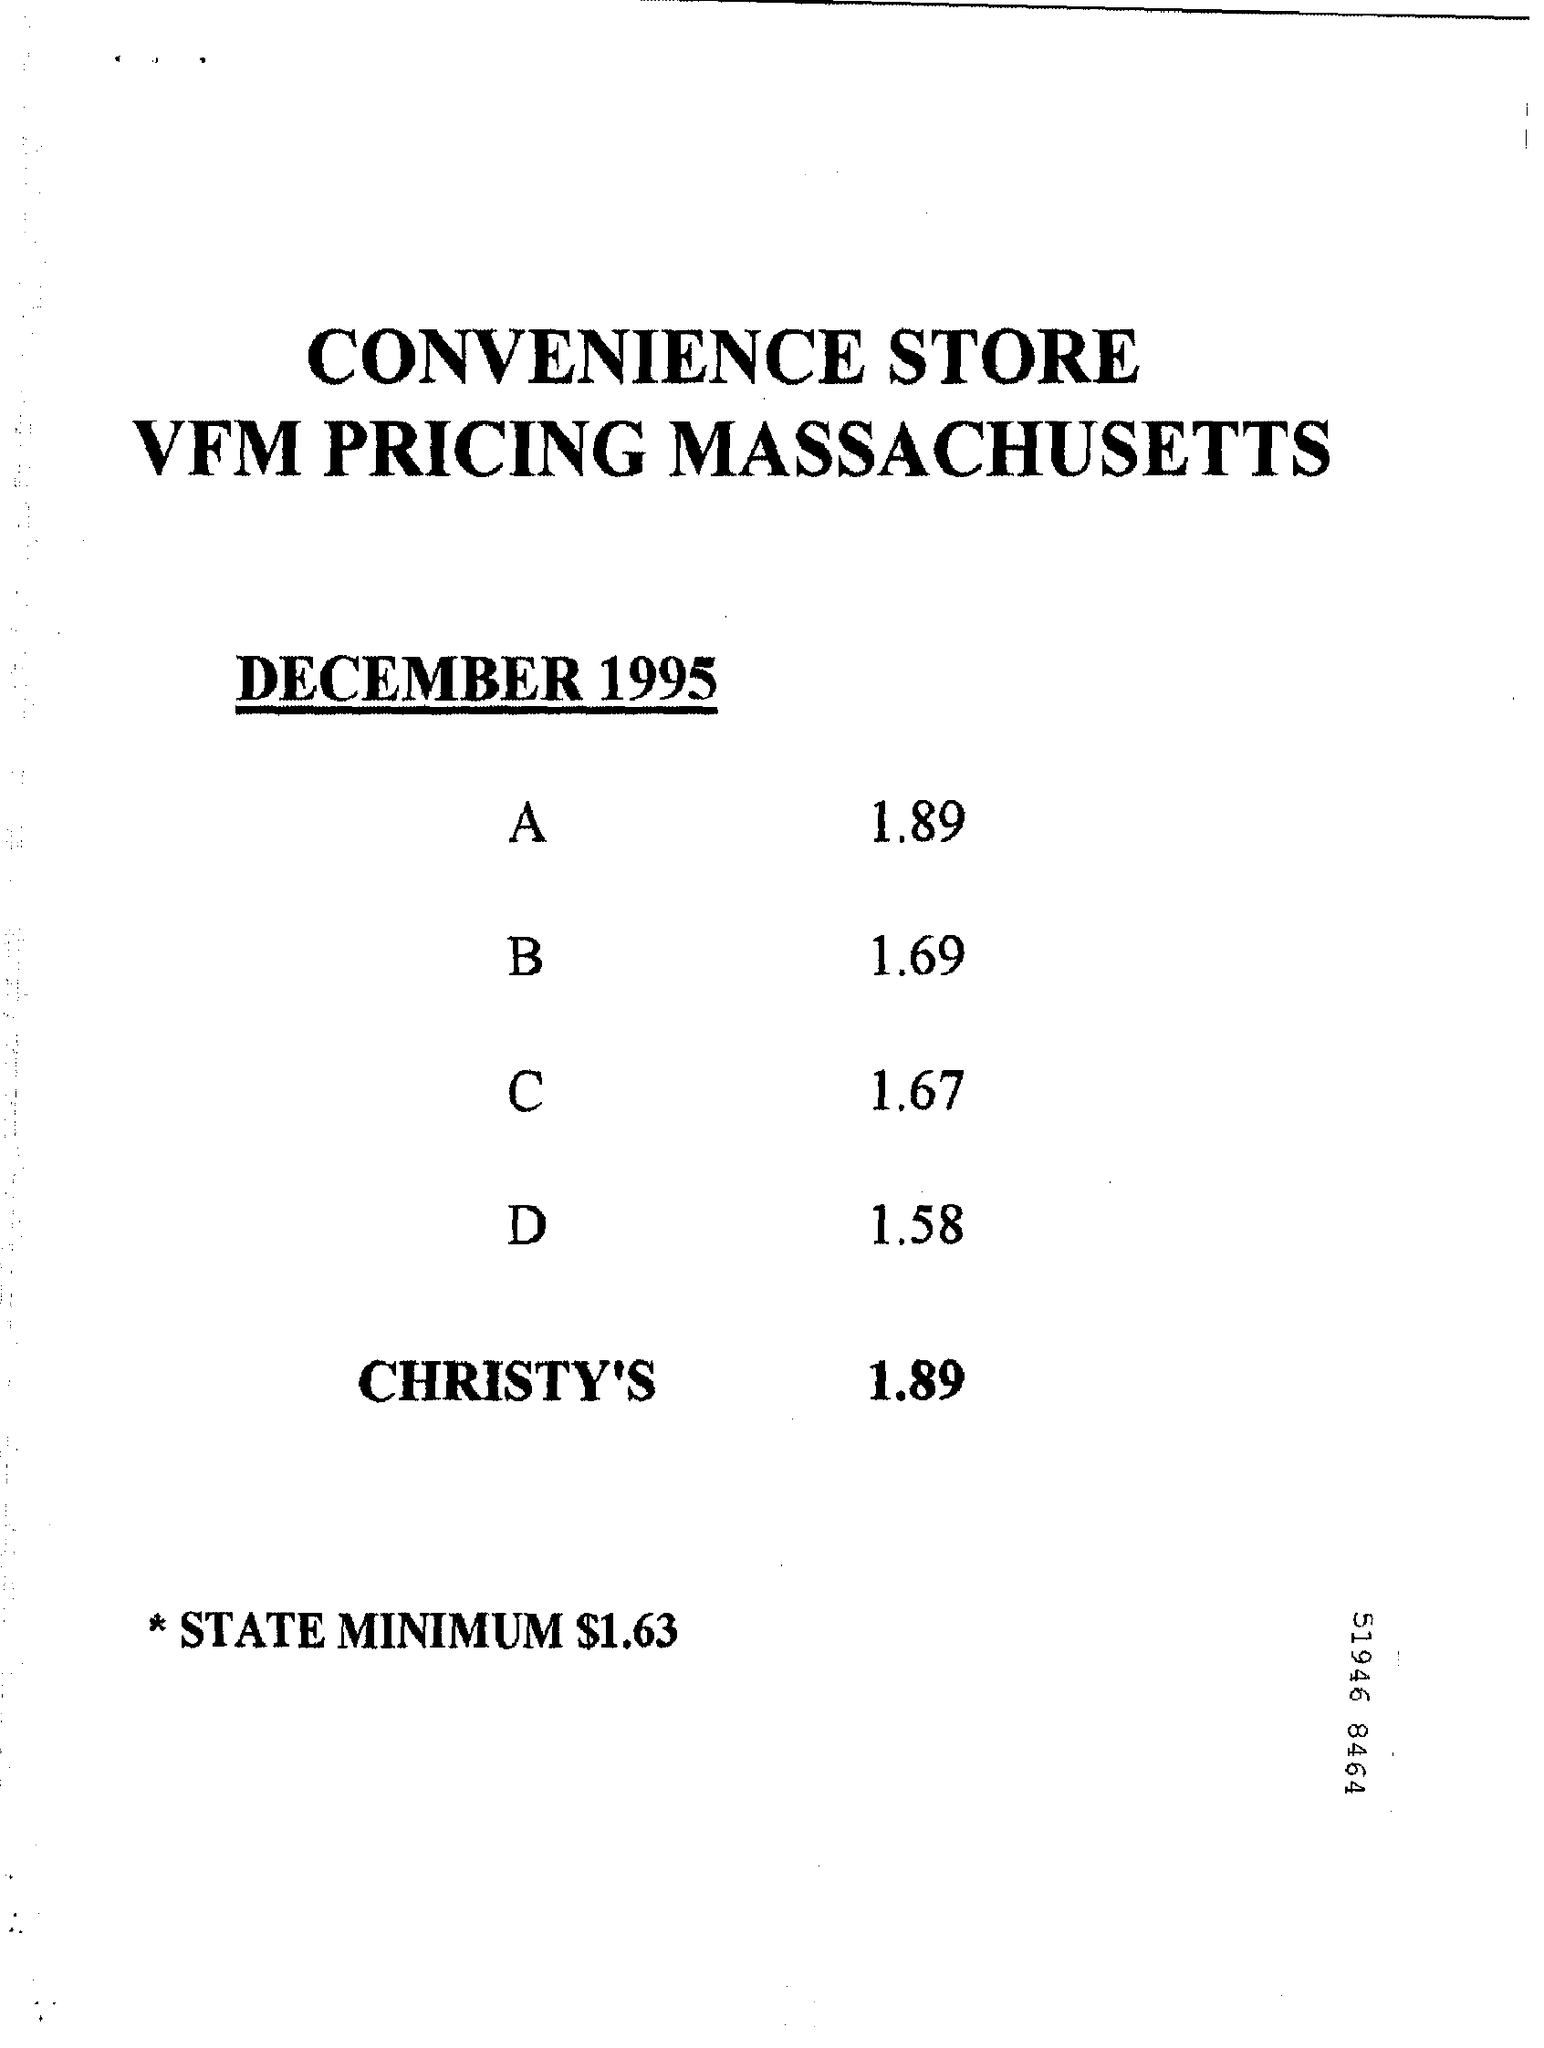Indicate a few pertinent items in this graphic. The document is dated December 1995. The minimum state wage is currently $1.63 per hour. The document title is "Convenience Store VFM Pricing in Massachusetts. 